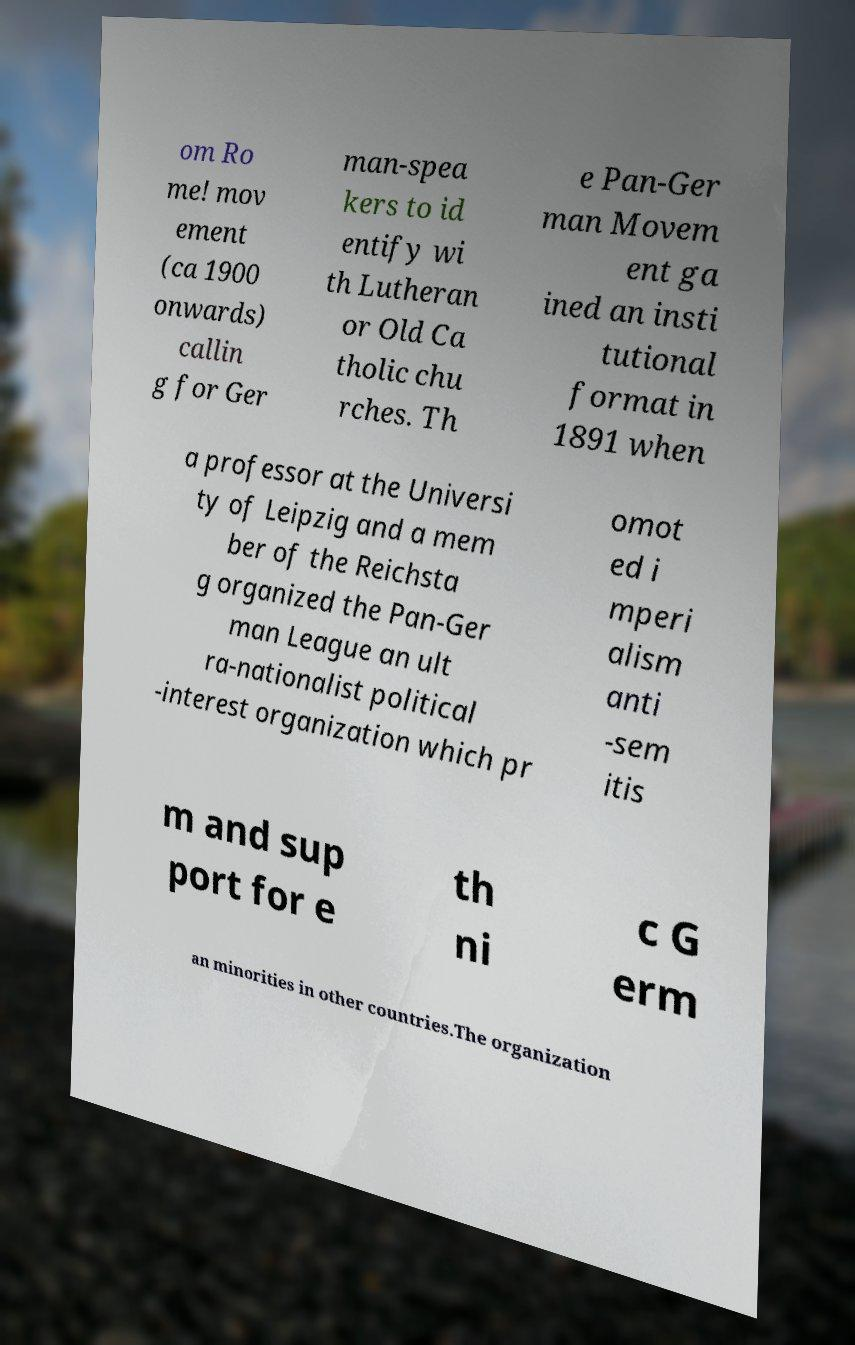Can you read and provide the text displayed in the image?This photo seems to have some interesting text. Can you extract and type it out for me? om Ro me! mov ement (ca 1900 onwards) callin g for Ger man-spea kers to id entify wi th Lutheran or Old Ca tholic chu rches. Th e Pan-Ger man Movem ent ga ined an insti tutional format in 1891 when a professor at the Universi ty of Leipzig and a mem ber of the Reichsta g organized the Pan-Ger man League an ult ra-nationalist political -interest organization which pr omot ed i mperi alism anti -sem itis m and sup port for e th ni c G erm an minorities in other countries.The organization 